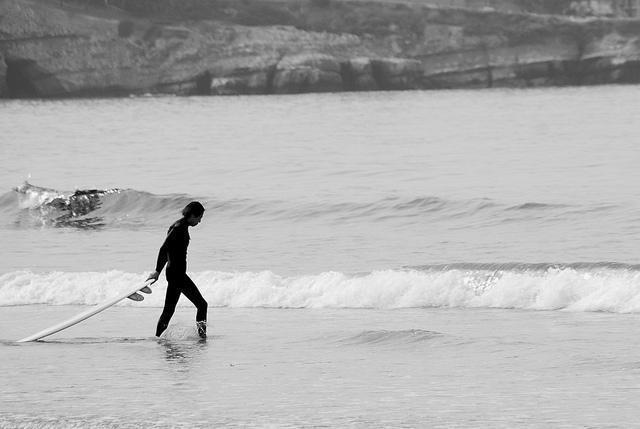How many waves are in the picture?
Give a very brief answer. 2. How many people are in the water?
Give a very brief answer. 1. 